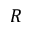<formula> <loc_0><loc_0><loc_500><loc_500>R</formula> 